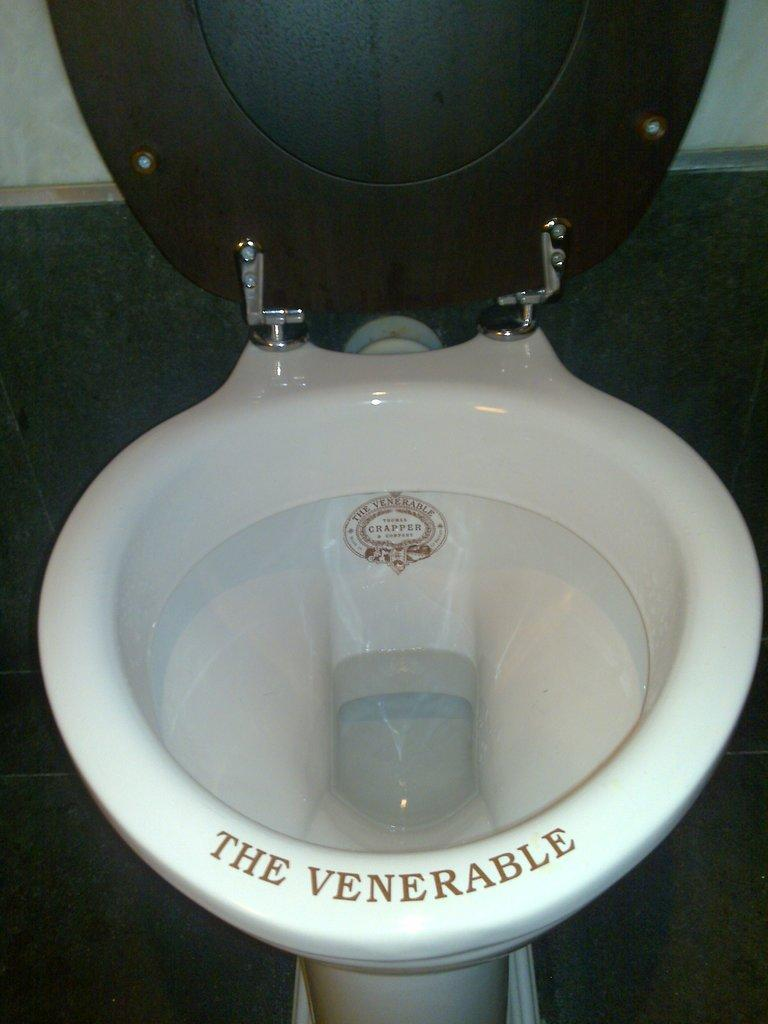<image>
Render a clear and concise summary of the photo. An open toilet with the words The Venerable written on the rim of the bowl. 